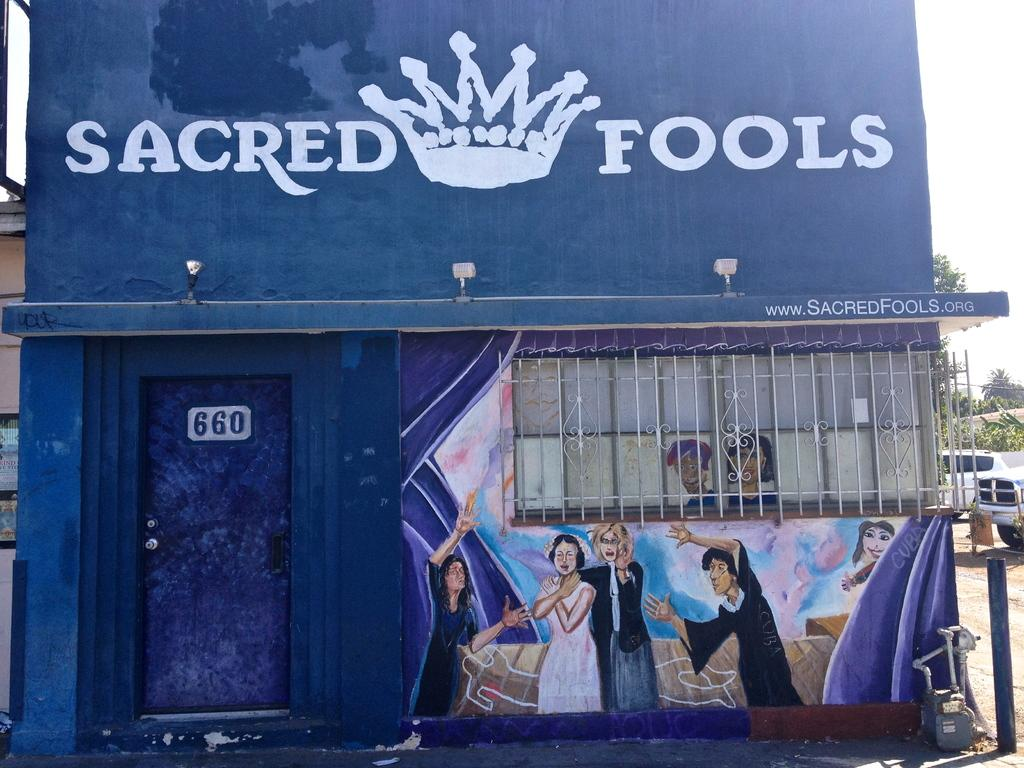What type of structure is visible in the image? There is a house in the image. What decorative elements are present on the house? The house has paintings on it. What can be seen behind the house? There are cars, trees, and other houses behind the house. How many roofs can be seen on the fifth house in the image? There is no mention of a fifth house in the image, and therefore no specific roof can be identified. 